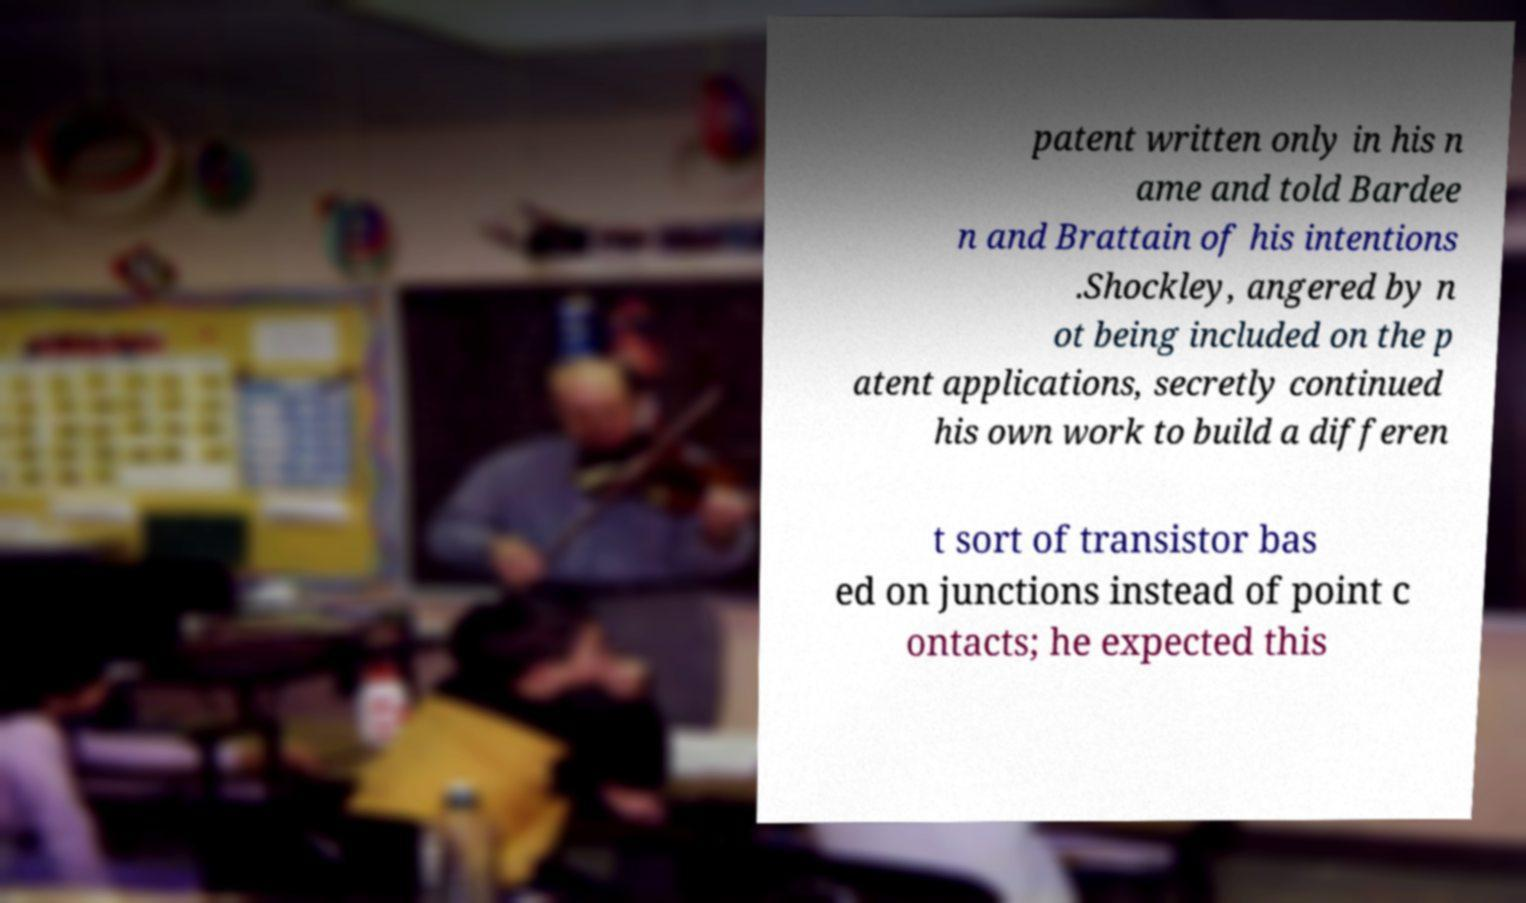Could you extract and type out the text from this image? patent written only in his n ame and told Bardee n and Brattain of his intentions .Shockley, angered by n ot being included on the p atent applications, secretly continued his own work to build a differen t sort of transistor bas ed on junctions instead of point c ontacts; he expected this 